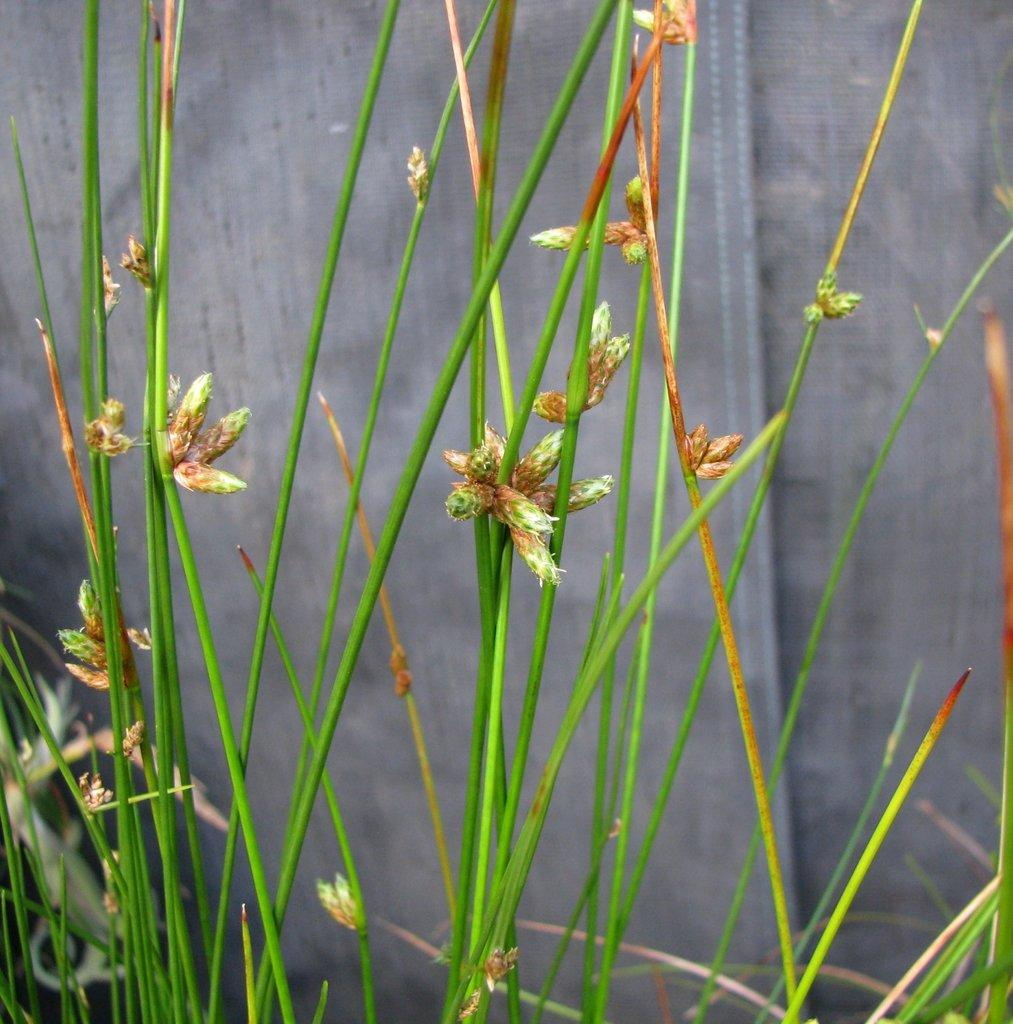What is the color of the grass in the image? The grass in the image is green. What type of structure can be seen in the image? There is a wall visible in the image. What is the color of the wall in the image? The wall is grey in color. How many parts of the van can be seen in the image? There is no van present in the image. What need does the wall in the image fulfill? The wall in the image does not fulfill a specific need; it is simply a part of the scene. 